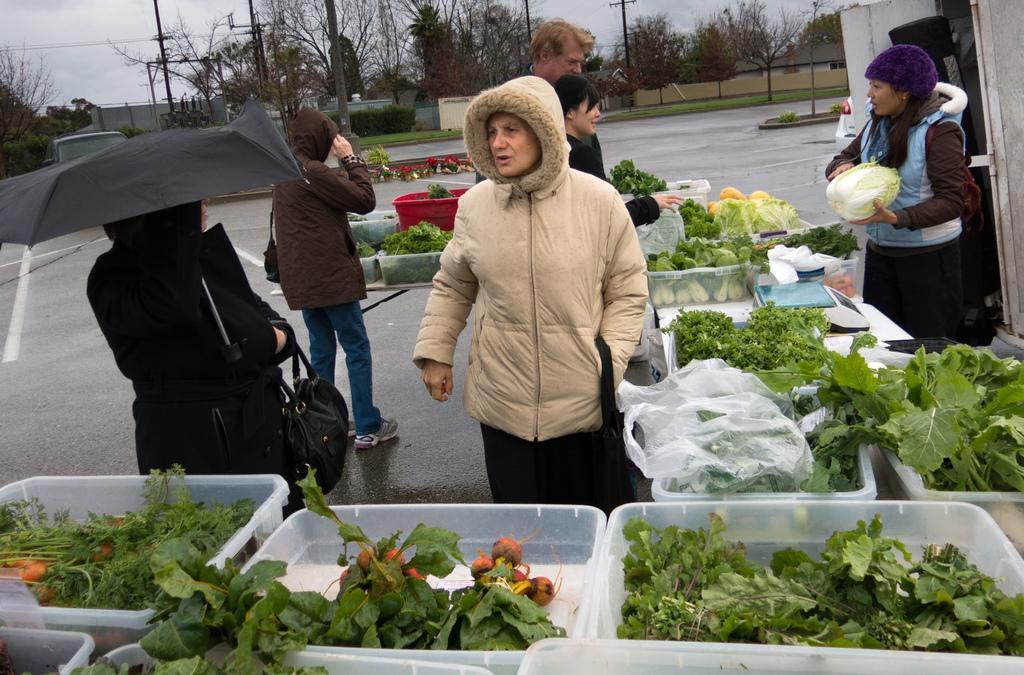Can you describe this image briefly? There are green leafy vegetable in white boxes. There are vegetables in polythene covers. A person at the right is holding a cabbage. There are people at the left. A person at the left corner is wearing a black dress and holding a black dress and black umbrella. There are electric poles, wires, trees and buildings at the back. 